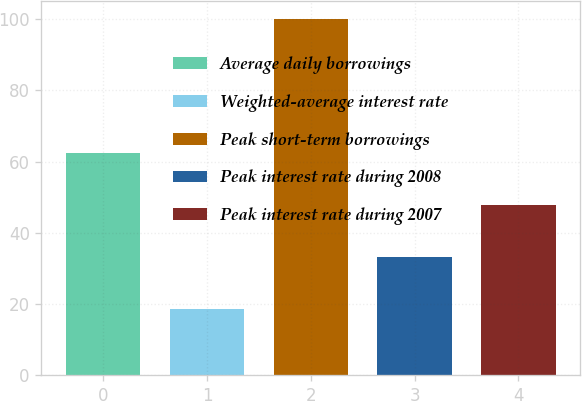Convert chart to OTSL. <chart><loc_0><loc_0><loc_500><loc_500><bar_chart><fcel>Average daily borrowings<fcel>Weighted-average interest rate<fcel>Peak short-term borrowings<fcel>Peak interest rate during 2008<fcel>Peak interest rate during 2007<nl><fcel>62.37<fcel>18.57<fcel>100<fcel>33.17<fcel>47.77<nl></chart> 